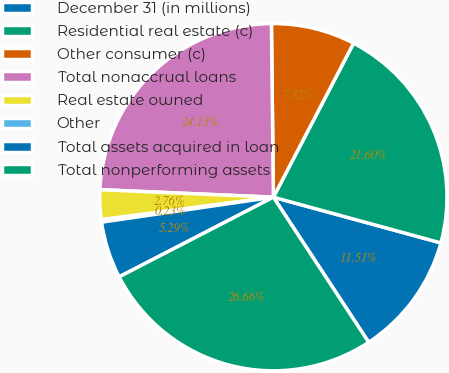<chart> <loc_0><loc_0><loc_500><loc_500><pie_chart><fcel>December 31 (in millions)<fcel>Residential real estate (c)<fcel>Other consumer (c)<fcel>Total nonaccrual loans<fcel>Real estate owned<fcel>Other<fcel>Total assets acquired in loan<fcel>Total nonperforming assets<nl><fcel>11.51%<fcel>21.6%<fcel>7.82%<fcel>24.13%<fcel>2.76%<fcel>0.23%<fcel>5.29%<fcel>26.66%<nl></chart> 